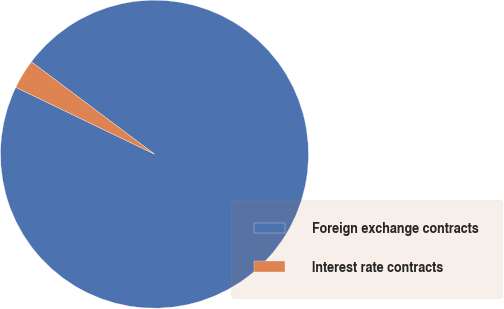Convert chart to OTSL. <chart><loc_0><loc_0><loc_500><loc_500><pie_chart><fcel>Foreign exchange contracts<fcel>Interest rate contracts<nl><fcel>96.9%<fcel>3.1%<nl></chart> 